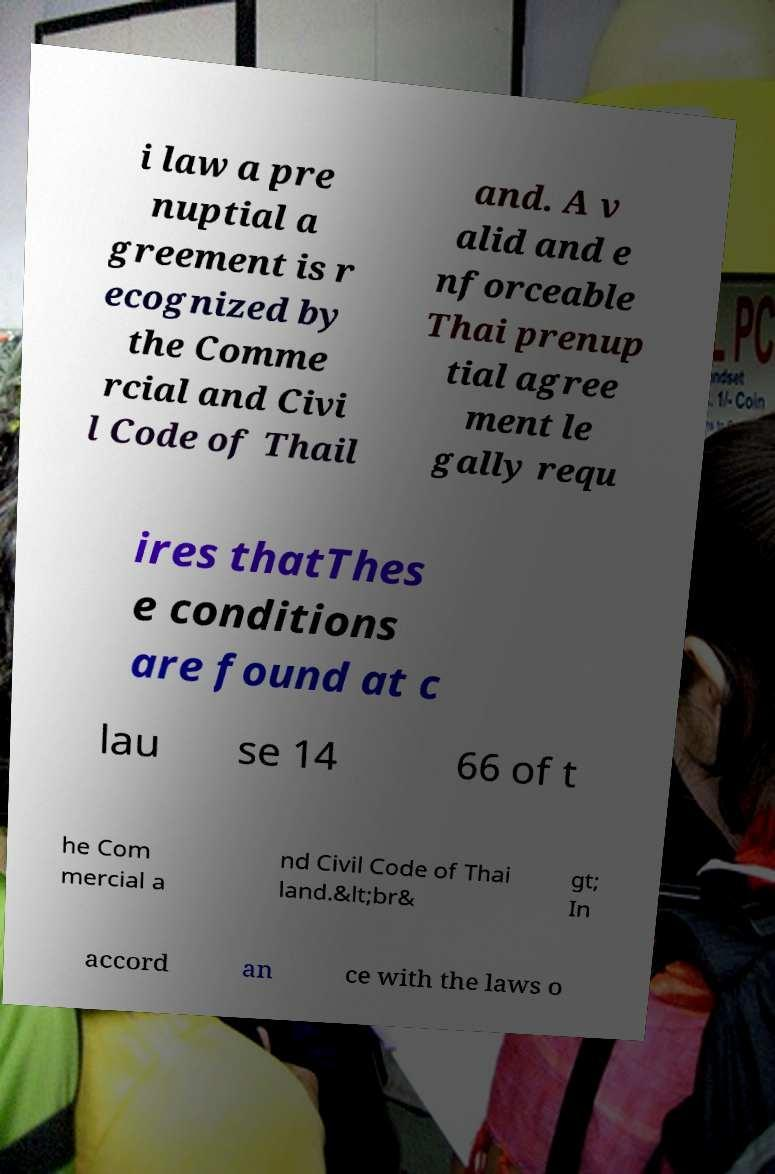Can you read and provide the text displayed in the image?This photo seems to have some interesting text. Can you extract and type it out for me? i law a pre nuptial a greement is r ecognized by the Comme rcial and Civi l Code of Thail and. A v alid and e nforceable Thai prenup tial agree ment le gally requ ires thatThes e conditions are found at c lau se 14 66 of t he Com mercial a nd Civil Code of Thai land.&lt;br& gt; In accord an ce with the laws o 